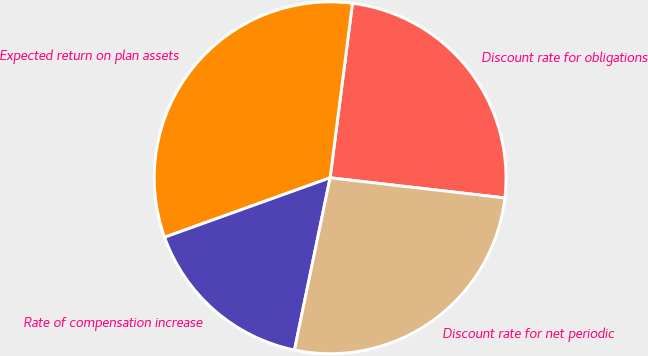<chart> <loc_0><loc_0><loc_500><loc_500><pie_chart><fcel>Discount rate for obligations<fcel>Expected return on plan assets<fcel>Rate of compensation increase<fcel>Discount rate for net periodic<nl><fcel>24.8%<fcel>32.52%<fcel>16.26%<fcel>26.42%<nl></chart> 